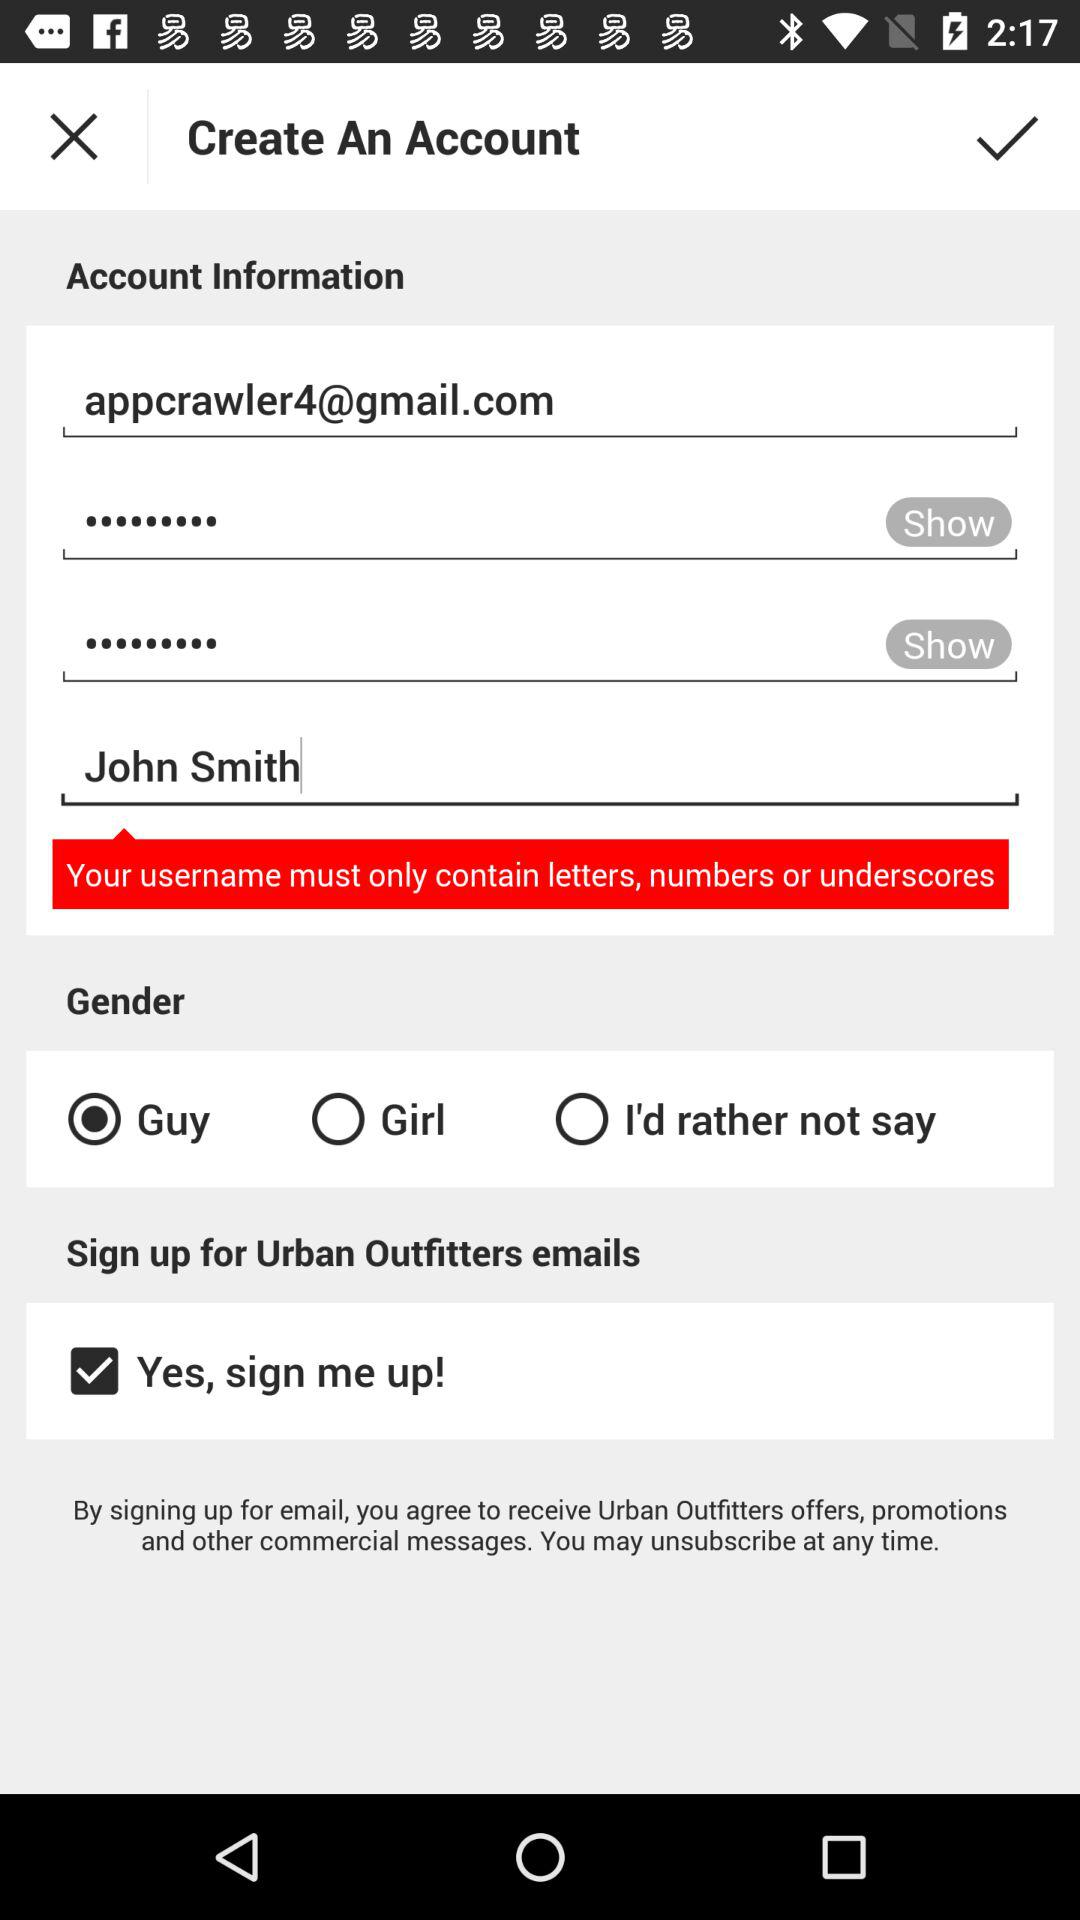How many gender options are there?
Answer the question using a single word or phrase. 3 